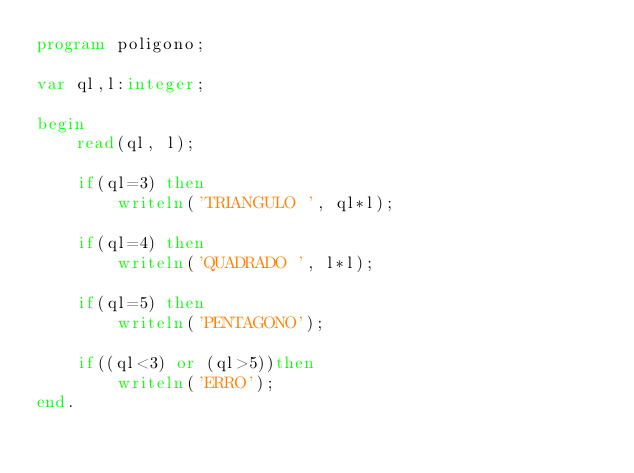<code> <loc_0><loc_0><loc_500><loc_500><_Pascal_>program poligono;

var ql,l:integer;

begin
    read(ql, l);
    
    if(ql=3) then 
        writeln('TRIANGULO ', ql*l);
    
    if(ql=4) then
        writeln('QUADRADO ', l*l);
        
    if(ql=5) then
        writeln('PENTAGONO');
        
    if((ql<3) or (ql>5))then
        writeln('ERRO');
end.
</code> 